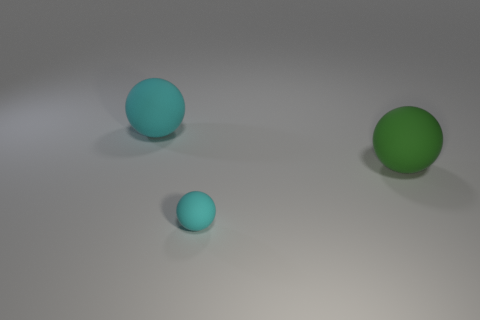There is a big rubber object in front of the cyan rubber sphere that is behind the small cyan sphere that is on the left side of the green matte ball; what shape is it?
Your response must be concise. Sphere. What shape is the green object that is the same material as the tiny ball?
Provide a succinct answer. Sphere. What size is the green thing?
Provide a succinct answer. Large. How many objects are either large matte balls to the right of the small matte object or cyan balls that are behind the tiny cyan matte ball?
Give a very brief answer. 2. What number of big cyan matte things are to the right of the cyan ball right of the large cyan thing that is left of the small rubber sphere?
Your response must be concise. 0. There is a cyan matte sphere that is on the left side of the tiny cyan thing; how big is it?
Keep it short and to the point. Large. What number of cyan spheres have the same size as the green rubber thing?
Make the answer very short. 1. There is a green ball; is it the same size as the sphere in front of the big green rubber sphere?
Your answer should be very brief. No. How many objects are either large green rubber things or big cyan balls?
Provide a short and direct response. 2. How many rubber balls are the same color as the tiny thing?
Make the answer very short. 1. 